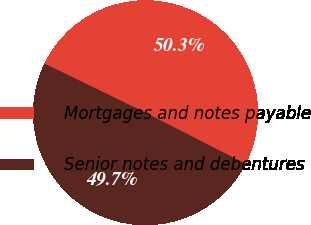Convert chart. <chart><loc_0><loc_0><loc_500><loc_500><pie_chart><fcel>Mortgages and notes payable<fcel>Senior notes and debentures<nl><fcel>50.32%<fcel>49.68%<nl></chart> 